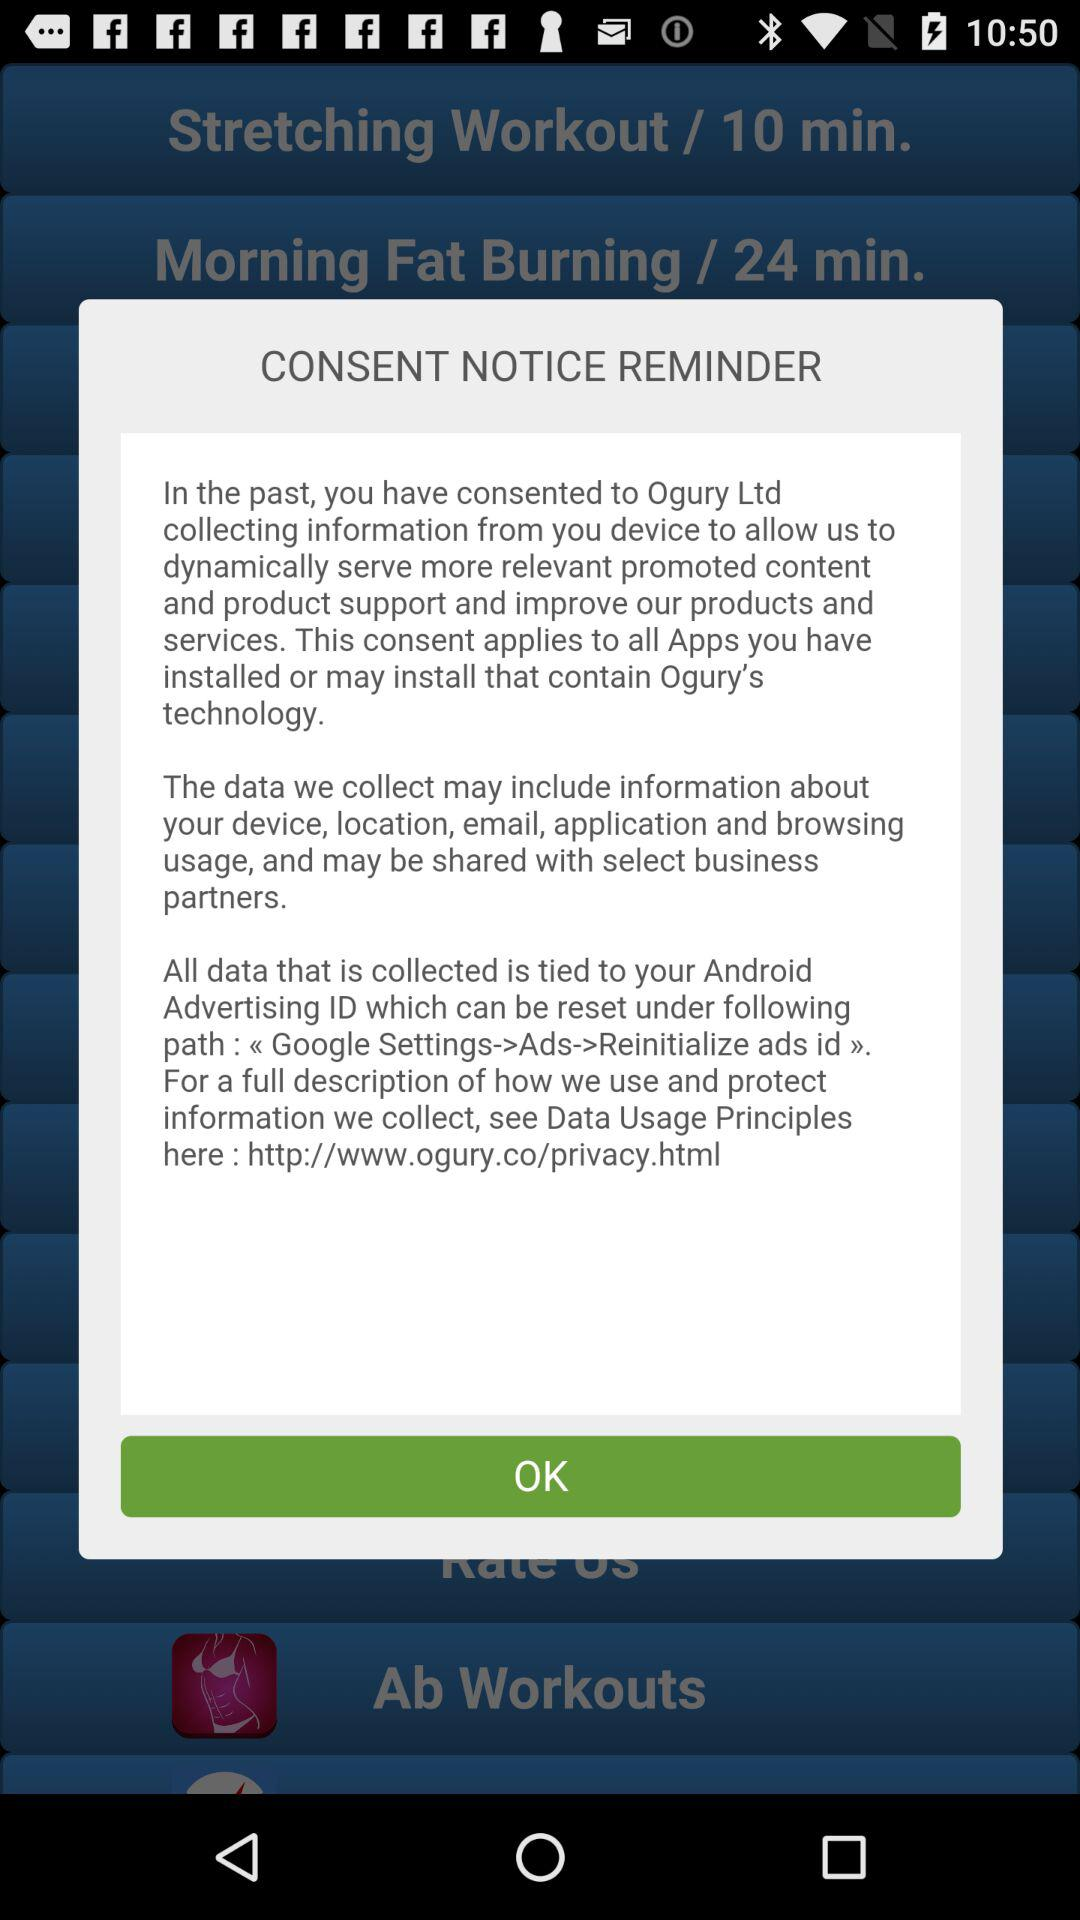What is the stretching workout time duration? The time duration is 10 minutes. 